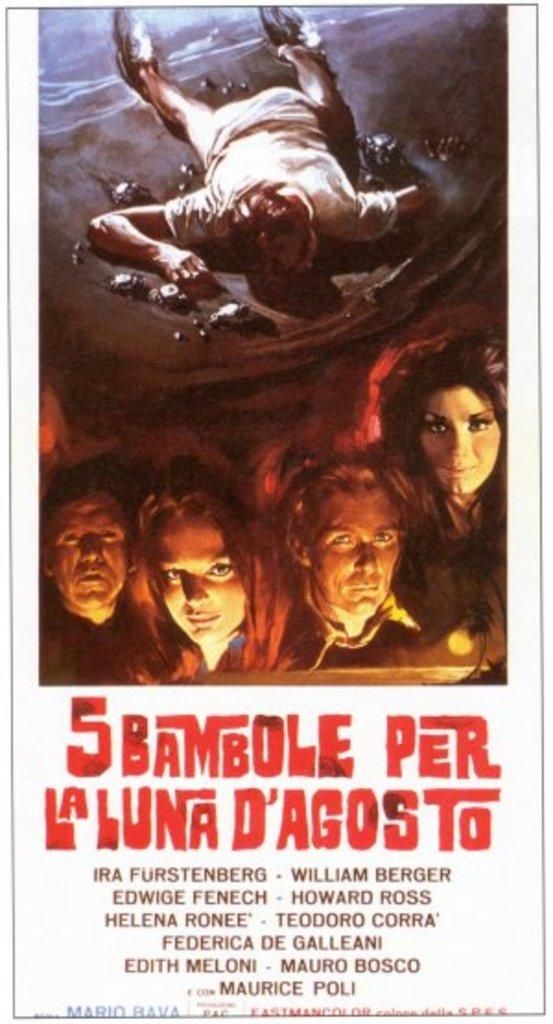<image>
Create a compact narrative representing the image presented. A movie poster is shown for 5 Bambole Per La Luna D'Agosto. 